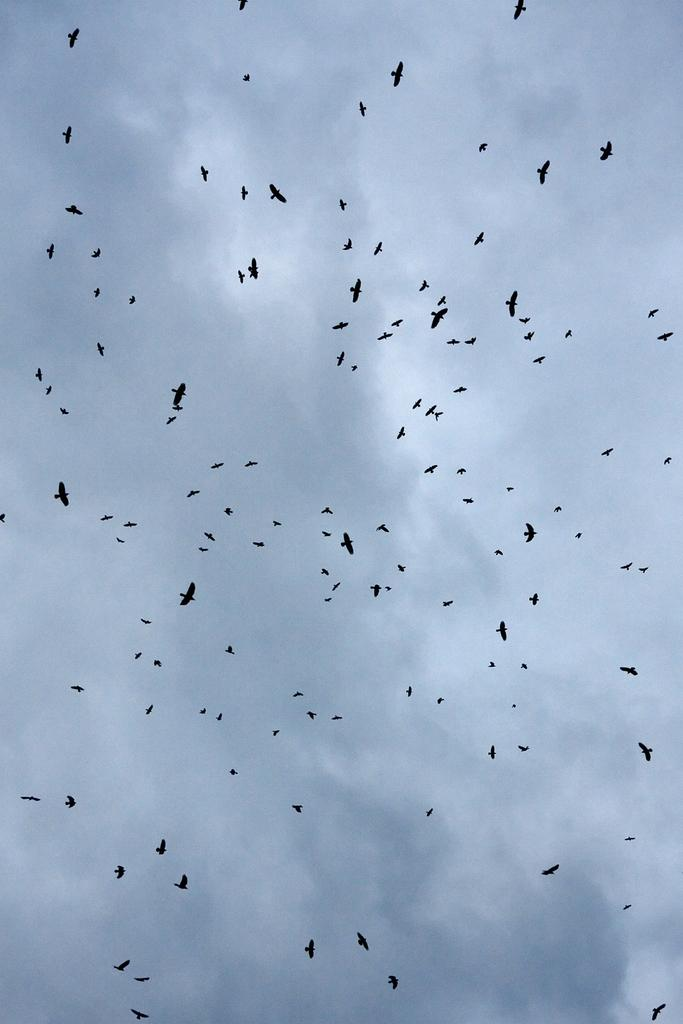What is happening in the image? There are many birds flying in the air. What can be seen in the background of the image? The sky is visible in the background. How would you describe the sky in the image? The sky appears to be cloudy. How many matches are being pulled by the birds in the image? There are no matches present in the image; it features birds flying in the sky. What type of land can be seen in the image? There is no land visible in the image, only the sky and birds. 